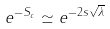<formula> <loc_0><loc_0><loc_500><loc_500>e ^ { - S _ { c } } \simeq e ^ { - 2 s \sqrt { \lambda } }</formula> 